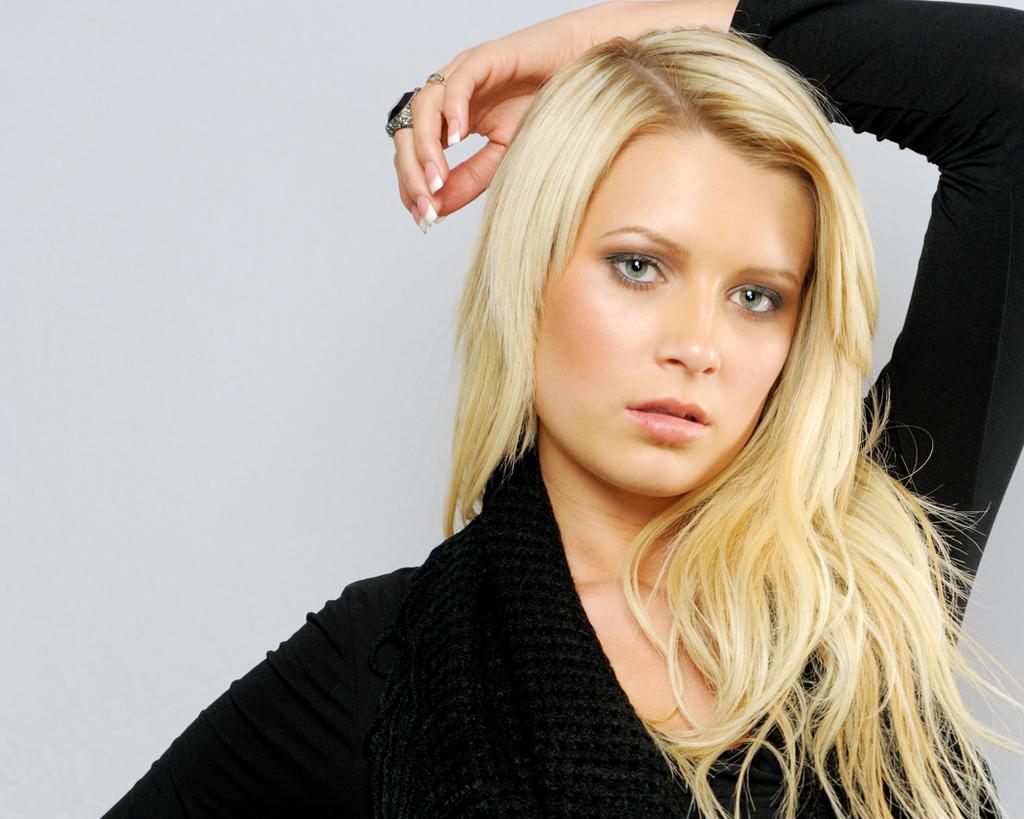Describe this image in one or two sentences. In this image we can see a lady is there and she wears black color dress and the black color ring and she has shot hair. 